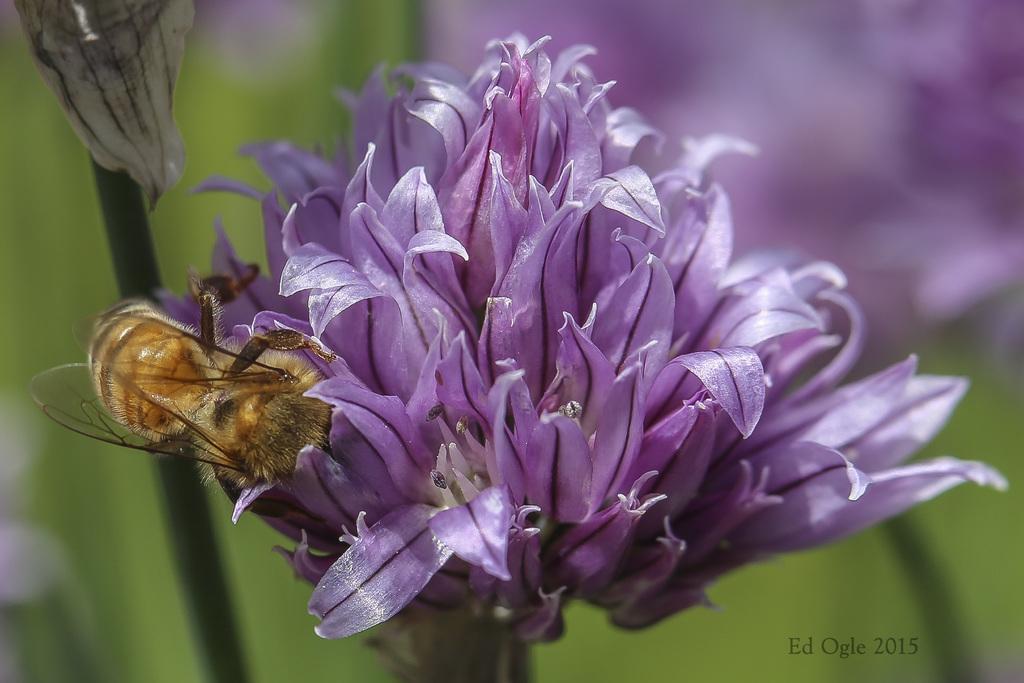Please provide a concise description of this image. In this image there is a violet color flower having a n insect on it. Left side there is a plant. Background there are few plants having flowers. 